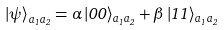<formula> <loc_0><loc_0><loc_500><loc_500>\left | \psi \right \rangle _ { a _ { 1 } a _ { 2 } } = \alpha \left | 0 0 \right \rangle _ { a _ { 1 } a _ { 2 } } + \beta \left | 1 1 \right \rangle _ { a _ { 1 } a _ { 2 } }</formula> 